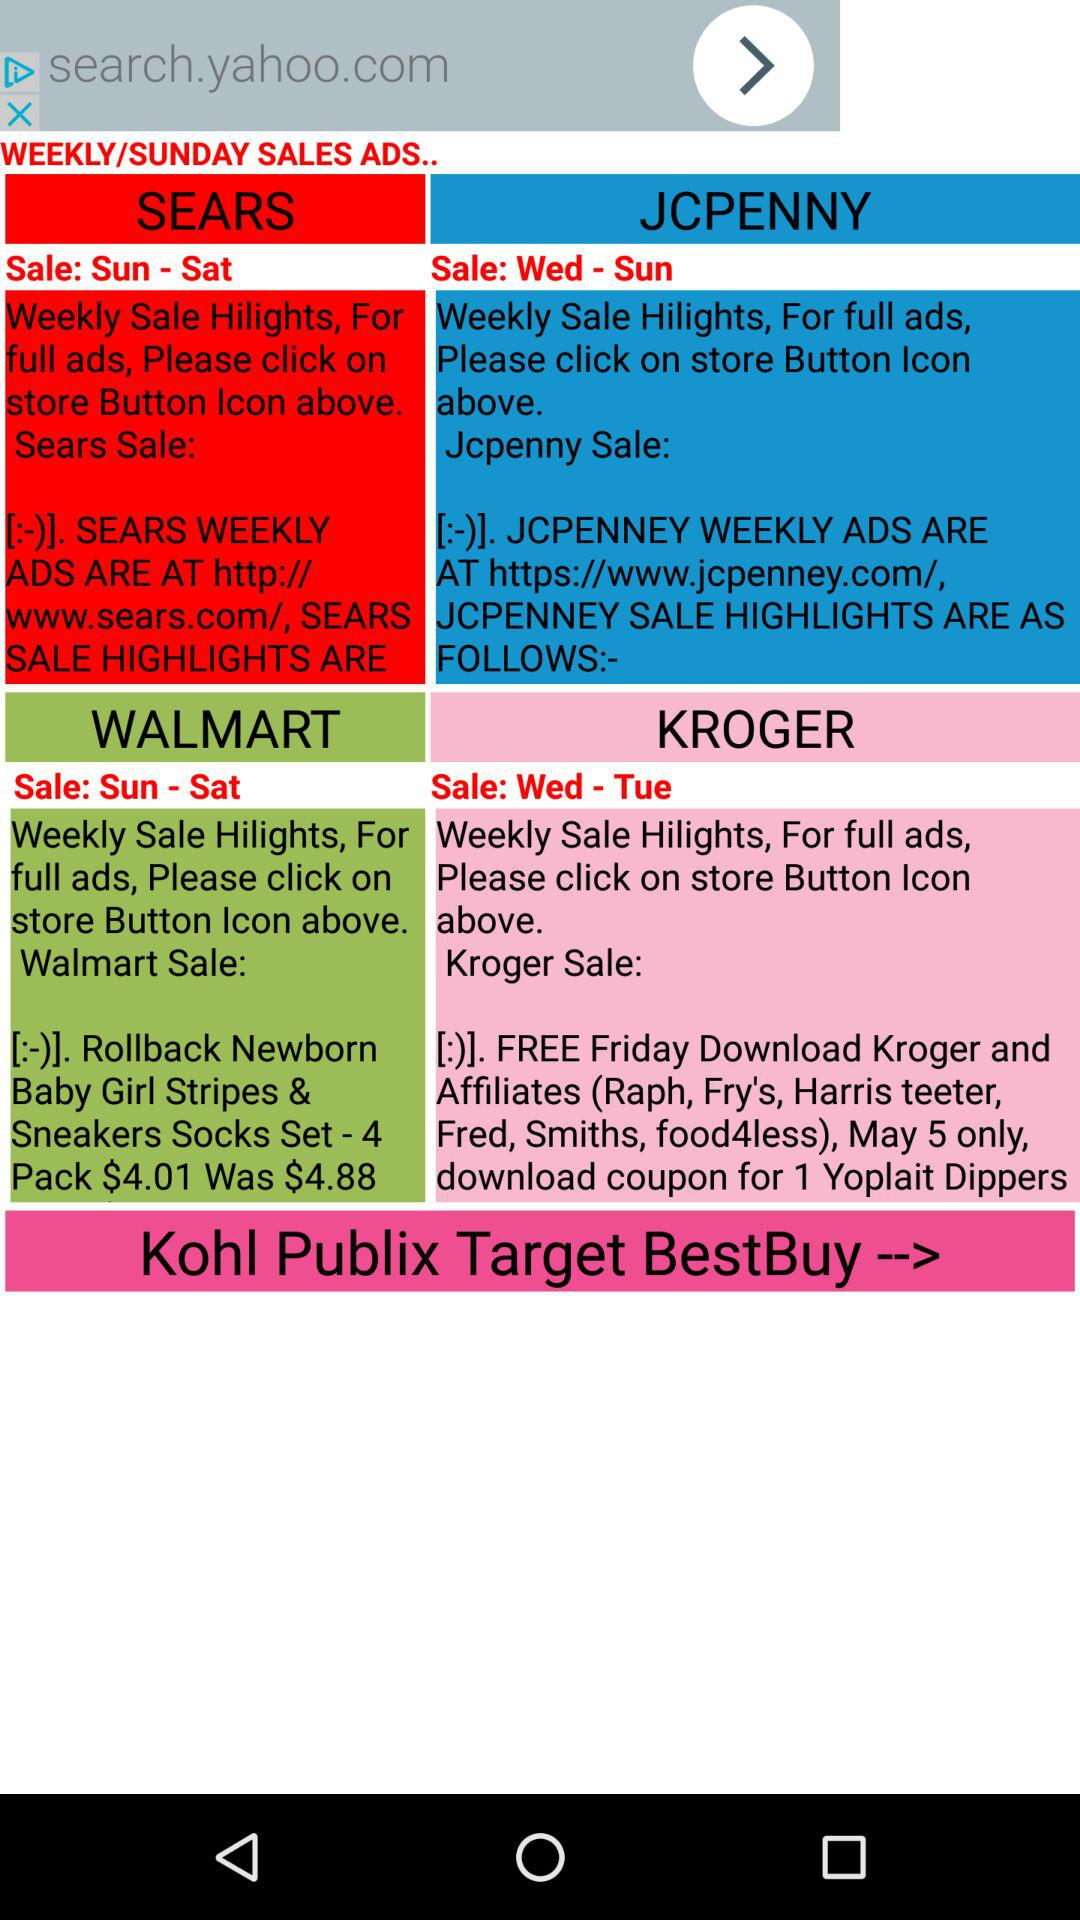What day is the next "Walmart" sale going to be? The days are Sunday and Saturday. 